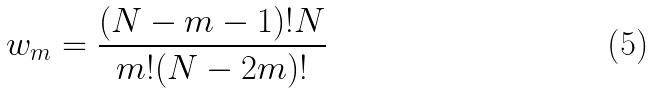Convert formula to latex. <formula><loc_0><loc_0><loc_500><loc_500>w _ { m } = \frac { ( N - m - 1 ) ! N } { m ! ( N - 2 m ) ! }</formula> 